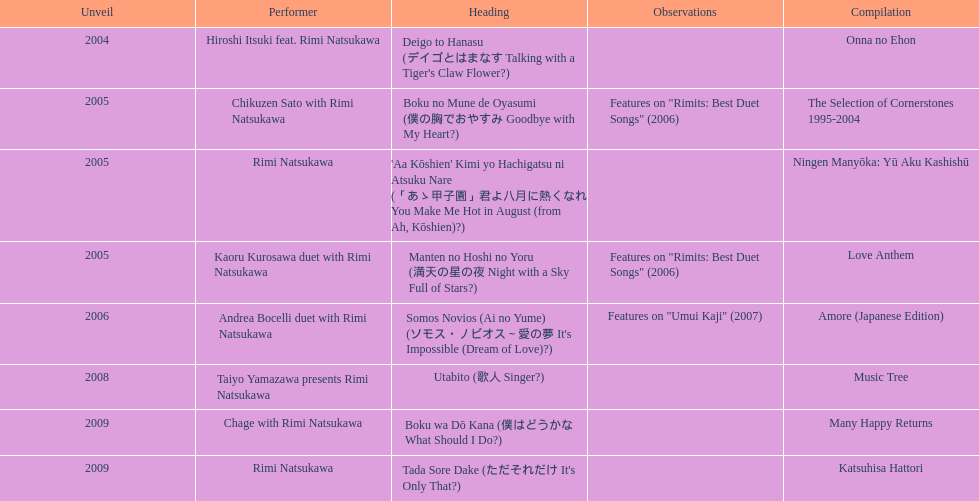Which year had the most titles released? 2005. 